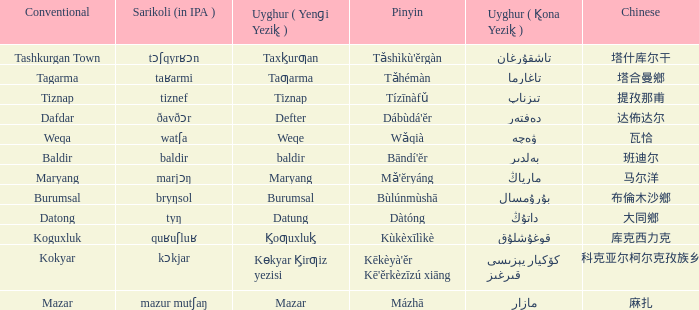Name the uyghur for  瓦恰 ۋەچە. 